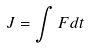<formula> <loc_0><loc_0><loc_500><loc_500>J = \int F d t</formula> 